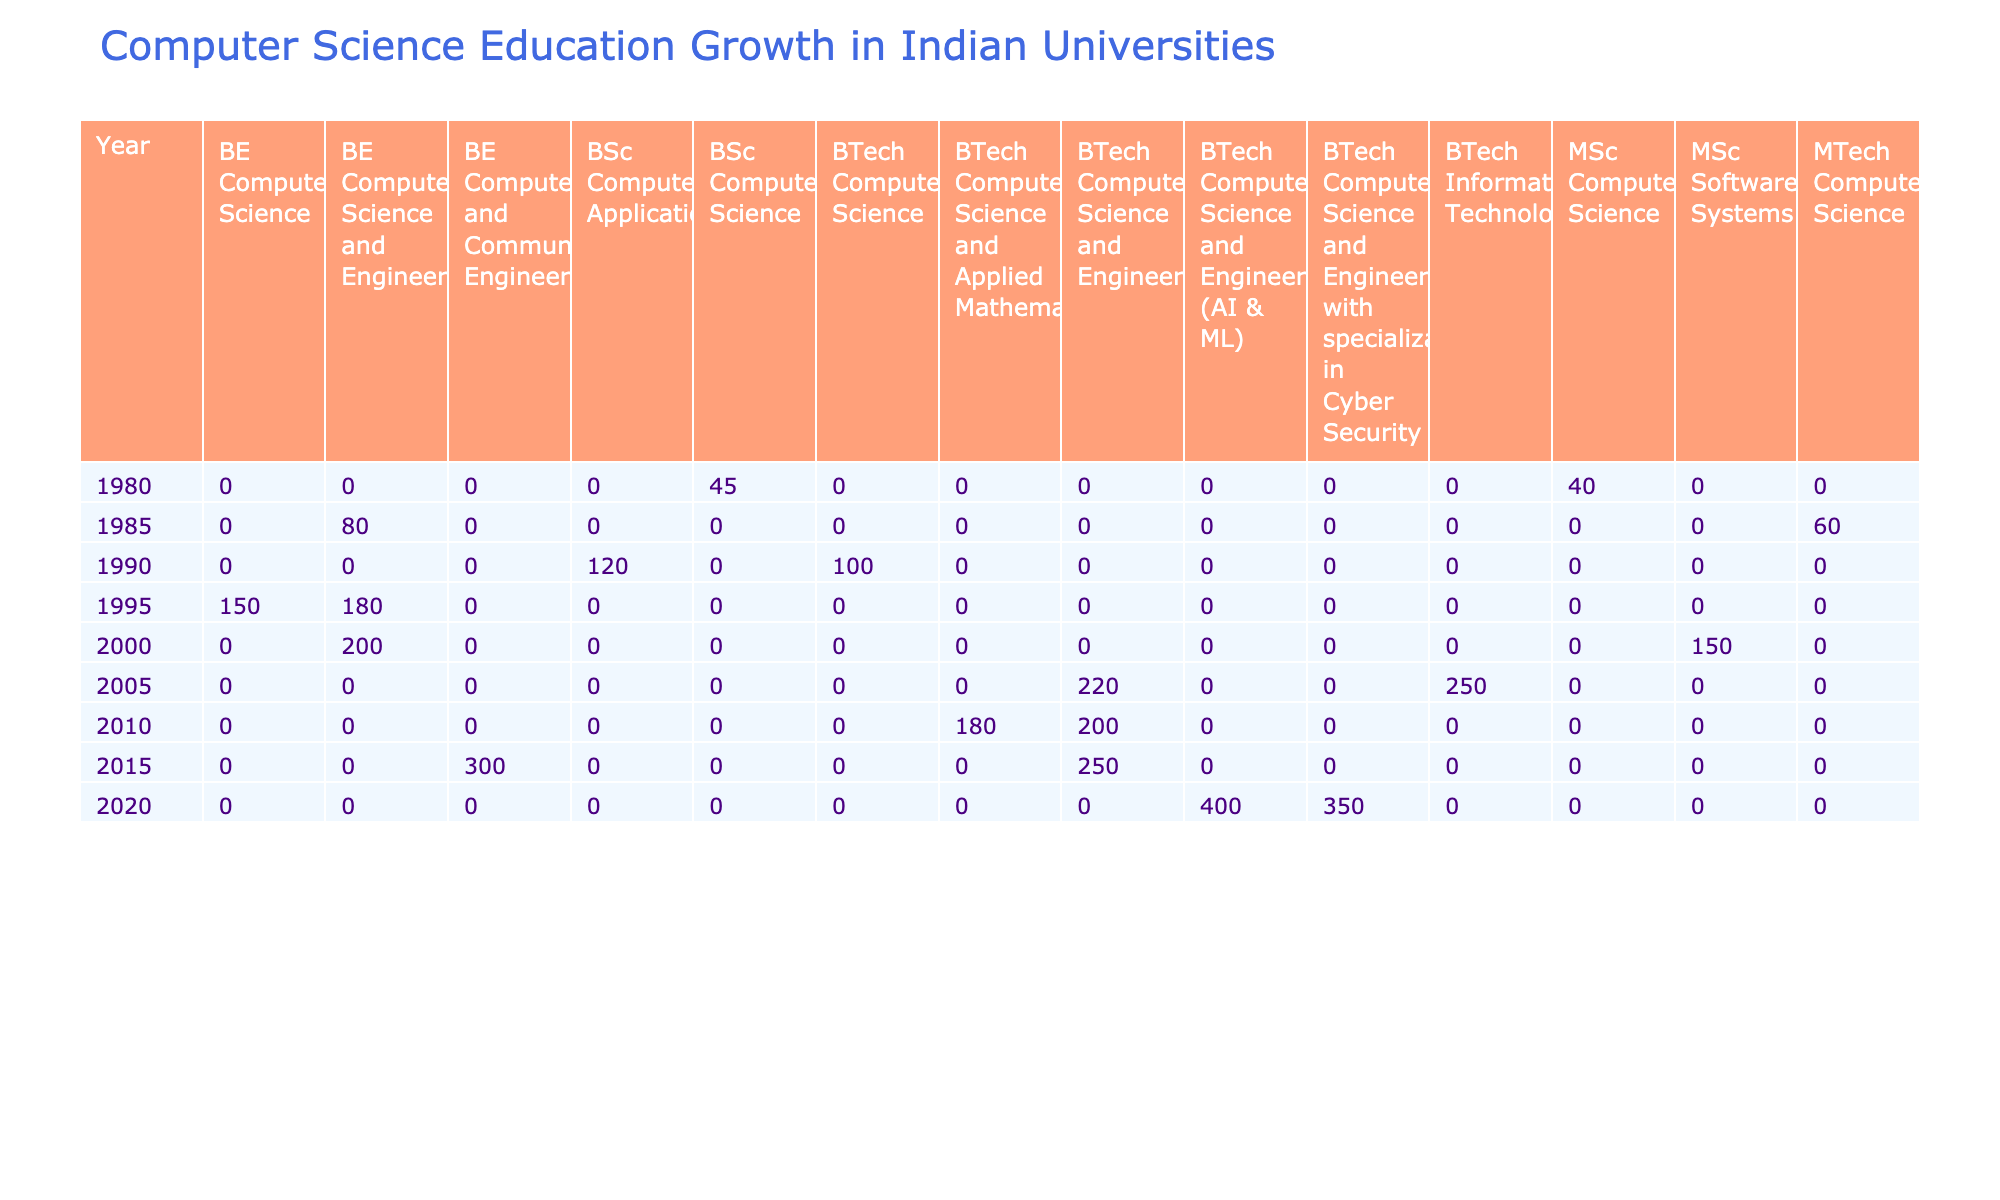What was the enrollment count for BSc Computer Science in 1980? The enrollment count for the BSc Computer Science program in 1980 at the Indian Institute of Technology Bombay is 45.
Answer: 45 Which program had the highest enrollment count in 2015? In 2015, the BE Computer and Communication Engineering program at Manipal Institute of Technology had the highest enrollment count of 300.
Answer: 300 What is the average graduate count from the BE Computer Science and Engineering program from 1995 to 2020? The graduate counts for this program over the given years are 165 (1995), 230 (2010), and 280 (2015). Summing these gives 675, and the average is 675/3 = 225.
Answer: 225 Did the University of Pune have a program with more than 50% female enrollment in any year? The maximum female percentage for the MSc Computer Science program at the University of Pune is 15%, which is less than 50%. Therefore, no program had more than 50% female enrollment.
Answer: No Which year saw the largest increase in enrollment count compared to the previous year? By analyzing the enrollment counts: 2015 (300) minus 2014 (not present) gives no prior data; 2020 (400) minus 2015 (300) equals 100; 2005 (250) minus 2000 (150) equals 100. Hence, the greatest increase is observed from 2015 to 2020.
Answer: 100 What percentage of the total enrollment in 2020 was female? In 2020, the total enrollment in the listed programs is 400 + 350 = 750, and the total number of female students across these programs is 0.45 * 400 + 0.42 * 350 = 180 + 147 = 327. The percentage is calculated as (327/750) * 100 = 43.6%.
Answer: 43.6% Which program had the highest number of industry partnerships in 2020? The BTech Computer Science and Engineering with specialization in Cyber Security at Vellore Institute of Technology had 22 industry partnerships in 2020, making it the program with the highest number.
Answer: 22 Was there an increase in the number of female students from 1990 to 1995? In 1990, there were 25 female students in BSc Computer Applications at the University of Delhi, and in 1995, there were 30 female students in BE Computer Science and Engineering at Anna University. Since this is not directly comparable, the female percentage is not given for 1995. Therefore, it cannot be concluded that there was a consistent increase.
Answer: Cannot determine What is the total enrollment count of all programs in 2005? In 2005: BTech Information Technology (250), BTech Computer Science and Engineering (220). The total enrollment is 250 + 220 = 470.
Answer: 470 